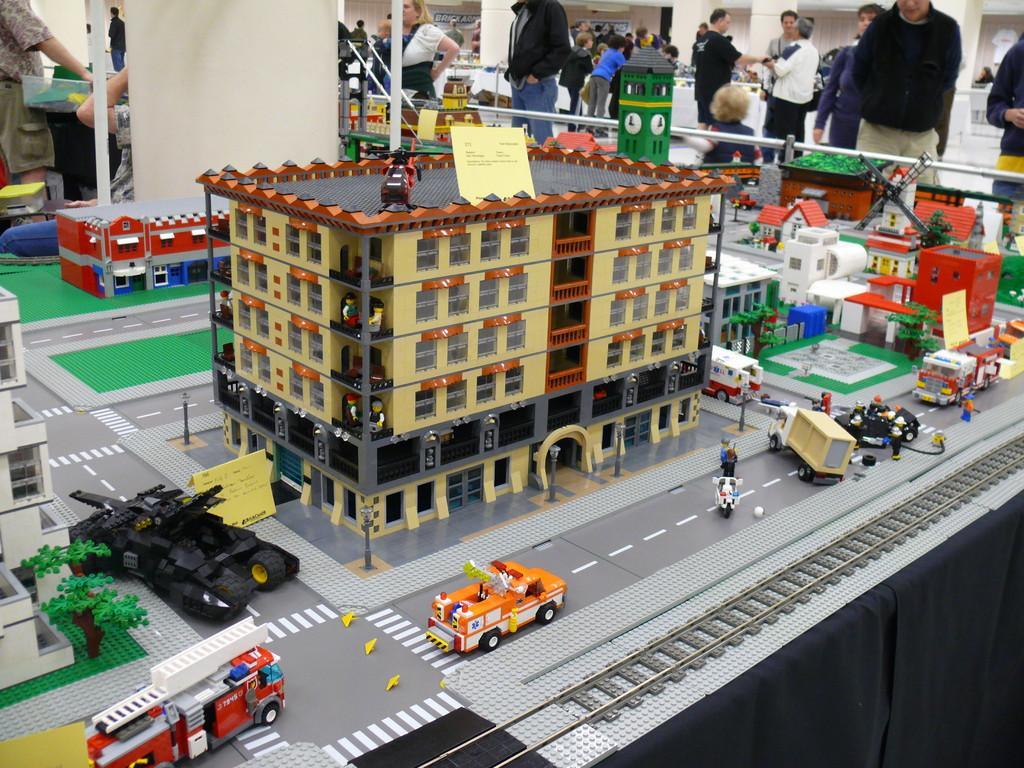Could you give a brief overview of what you see in this image? In this image we can see model of a building and vehicles. Background of the image people are standing. 